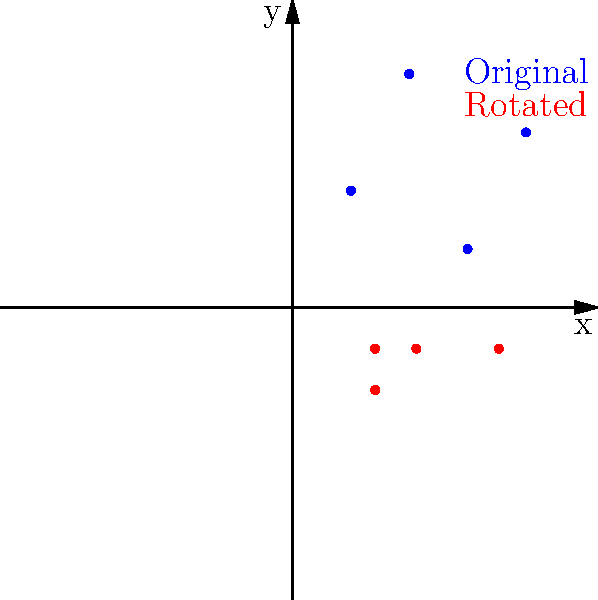Given a set of data points plotted on a scatter plot (shown in blue), you decide to rotate the points by 45 degrees clockwise around the origin to change the perspective (shown in red). What is the transformation matrix used to achieve this rotation? To rotate points around the origin by an angle $\theta$ clockwise, we use the following transformation matrix:

$$
R = \begin{bmatrix}
\cos\theta & \sin\theta \\
-\sin\theta & \cos\theta
\end{bmatrix}
$$

For a 45-degree clockwise rotation:

1. $\theta = 45°$
2. $\cos(45°) = \frac{\sqrt{2}}{2}$
3. $\sin(45°) = \frac{\sqrt{2}}{2}$

Substituting these values into the rotation matrix:

$$
R = \begin{bmatrix}
\frac{\sqrt{2}}{2} & \frac{\sqrt{2}}{2} \\
-\frac{\sqrt{2}}{2} & \frac{\sqrt{2}}{2}
\end{bmatrix}
$$

This matrix, when multiplied with the original coordinates $(x, y)$, will produce the rotated coordinates $(x', y')$:

$$
\begin{bmatrix}
x' \\
y'
\end{bmatrix} = 
\begin{bmatrix}
\frac{\sqrt{2}}{2} & \frac{\sqrt{2}}{2} \\
-\frac{\sqrt{2}}{2} & \frac{\sqrt{2}}{2}
\end{bmatrix}
\begin{bmatrix}
x \\
y
\end{bmatrix}
$$

This transformation matrix will rotate all points in the dataset by 45 degrees clockwise around the origin, as shown in the scatter plot with the red points representing the rotated data.
Answer: $$\begin{bmatrix}
\frac{\sqrt{2}}{2} & \frac{\sqrt{2}}{2} \\
-\frac{\sqrt{2}}{2} & \frac{\sqrt{2}}{2}
\end{bmatrix}$$ 